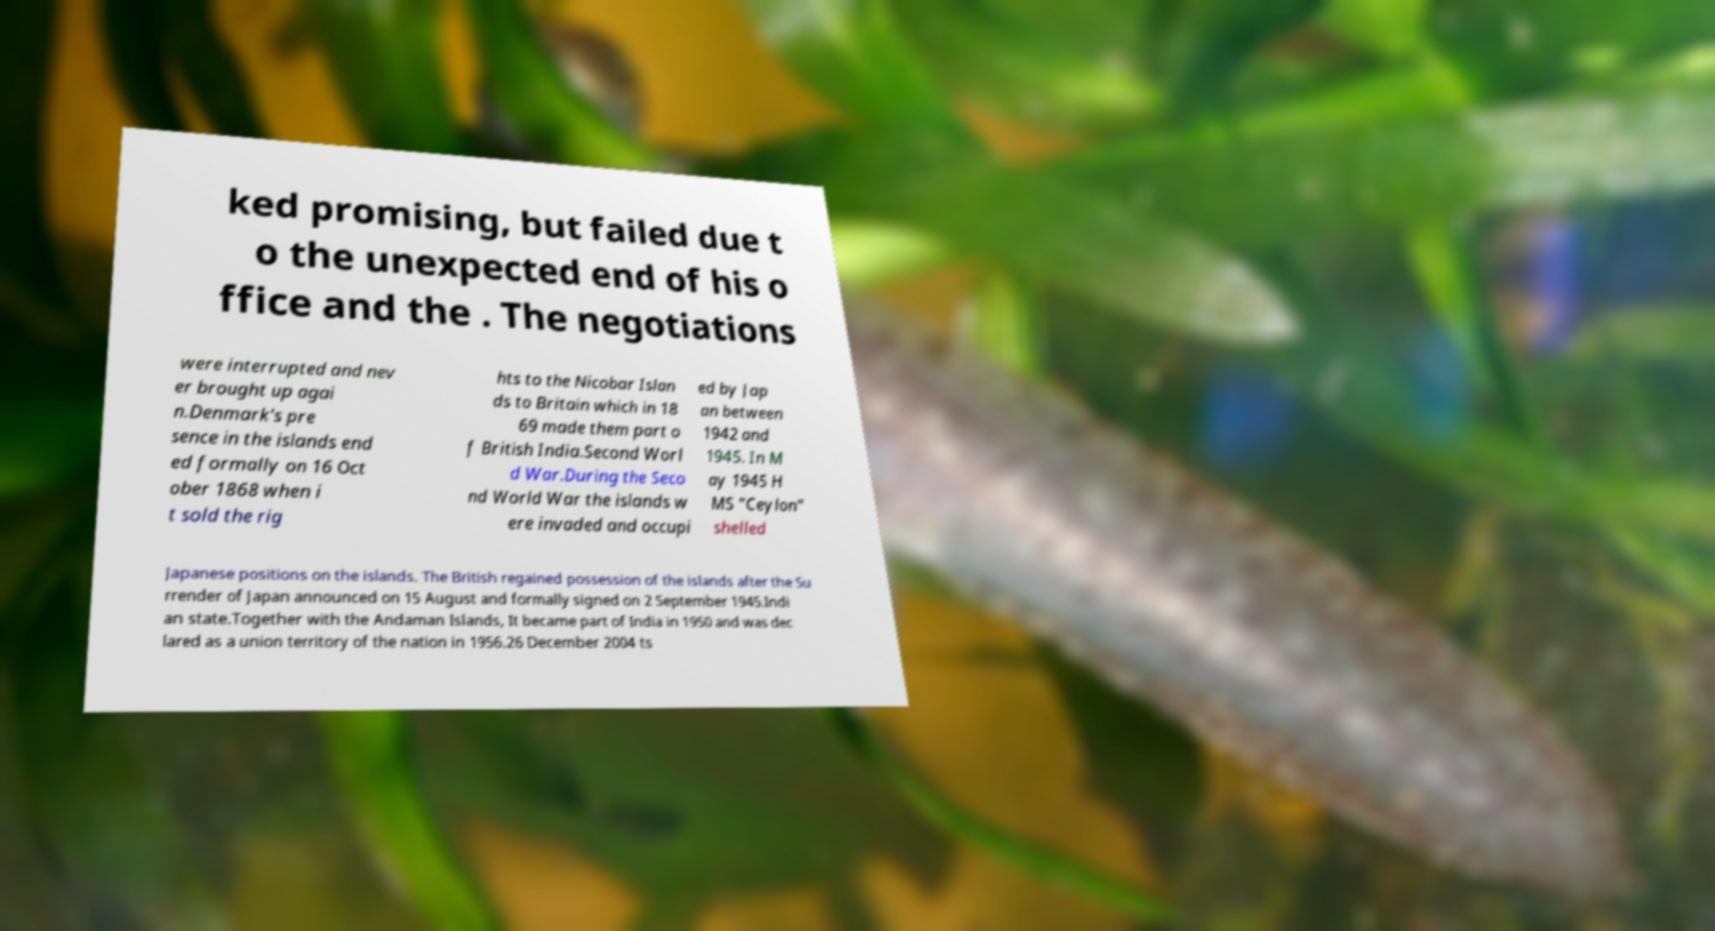Could you assist in decoding the text presented in this image and type it out clearly? ked promising, but failed due t o the unexpected end of his o ffice and the . The negotiations were interrupted and nev er brought up agai n.Denmark's pre sence in the islands end ed formally on 16 Oct ober 1868 when i t sold the rig hts to the Nicobar Islan ds to Britain which in 18 69 made them part o f British India.Second Worl d War.During the Seco nd World War the islands w ere invaded and occupi ed by Jap an between 1942 and 1945. In M ay 1945 H MS "Ceylon" shelled Japanese positions on the islands. The British regained possession of the islands after the Su rrender of Japan announced on 15 August and formally signed on 2 September 1945.Indi an state.Together with the Andaman Islands, It became part of India in 1950 and was dec lared as a union territory of the nation in 1956.26 December 2004 ts 